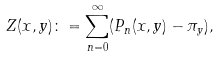<formula> <loc_0><loc_0><loc_500><loc_500>Z ( x , y ) \colon = \sum _ { n = 0 } ^ { \infty } ( P _ { n } ( x , y ) - \pi _ { y } ) ,</formula> 